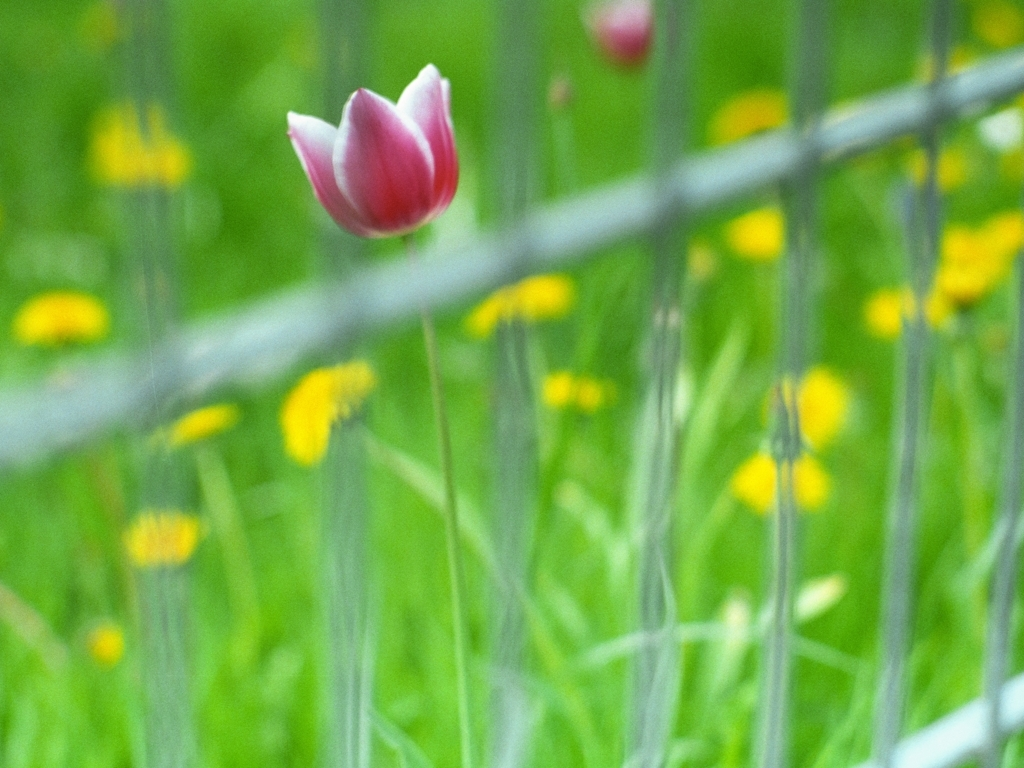What time of year does this image suggest and why? The photo suggests it could be springtime, as the presence of a blooming tulip and bright green grass are typical hallmarks of this season. Tulips usually bloom in spring, and the lush greenery generally indicates the resurgence of plant life after winter. 